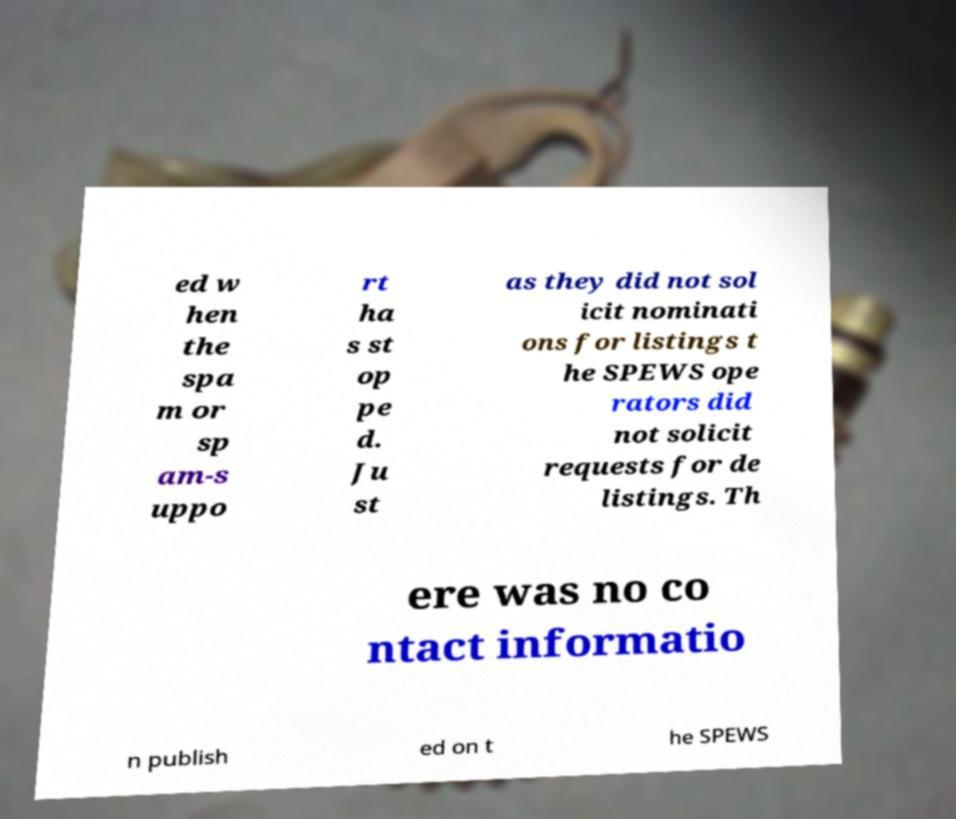Could you assist in decoding the text presented in this image and type it out clearly? ed w hen the spa m or sp am-s uppo rt ha s st op pe d. Ju st as they did not sol icit nominati ons for listings t he SPEWS ope rators did not solicit requests for de listings. Th ere was no co ntact informatio n publish ed on t he SPEWS 